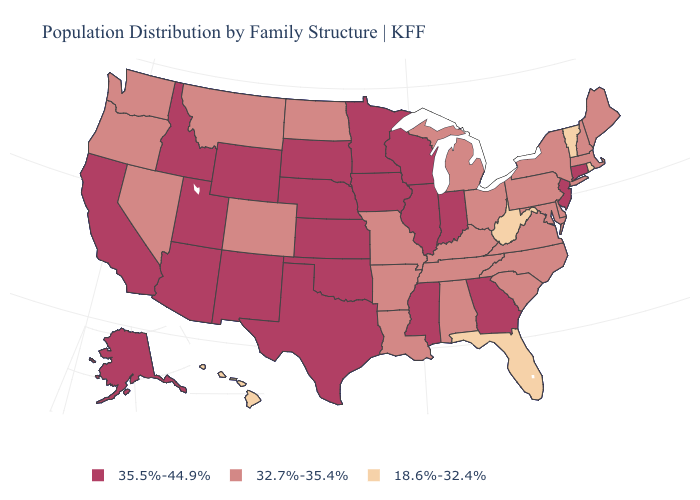How many symbols are there in the legend?
Short answer required. 3. What is the value of Oregon?
Give a very brief answer. 32.7%-35.4%. Name the states that have a value in the range 32.7%-35.4%?
Short answer required. Alabama, Arkansas, Colorado, Delaware, Kentucky, Louisiana, Maine, Maryland, Massachusetts, Michigan, Missouri, Montana, Nevada, New Hampshire, New York, North Carolina, North Dakota, Ohio, Oregon, Pennsylvania, South Carolina, Tennessee, Virginia, Washington. Which states have the lowest value in the Northeast?
Write a very short answer. Rhode Island, Vermont. Does Montana have the highest value in the West?
Concise answer only. No. Name the states that have a value in the range 35.5%-44.9%?
Write a very short answer. Alaska, Arizona, California, Connecticut, Georgia, Idaho, Illinois, Indiana, Iowa, Kansas, Minnesota, Mississippi, Nebraska, New Jersey, New Mexico, Oklahoma, South Dakota, Texas, Utah, Wisconsin, Wyoming. Name the states that have a value in the range 18.6%-32.4%?
Short answer required. Florida, Hawaii, Rhode Island, Vermont, West Virginia. What is the value of Indiana?
Be succinct. 35.5%-44.9%. Among the states that border Massachusetts , which have the lowest value?
Answer briefly. Rhode Island, Vermont. What is the value of Idaho?
Keep it brief. 35.5%-44.9%. What is the value of South Dakota?
Keep it brief. 35.5%-44.9%. Among the states that border South Carolina , does North Carolina have the highest value?
Concise answer only. No. Does Florida have the lowest value in the USA?
Answer briefly. Yes. What is the value of Wyoming?
Quick response, please. 35.5%-44.9%. What is the value of Washington?
Keep it brief. 32.7%-35.4%. 